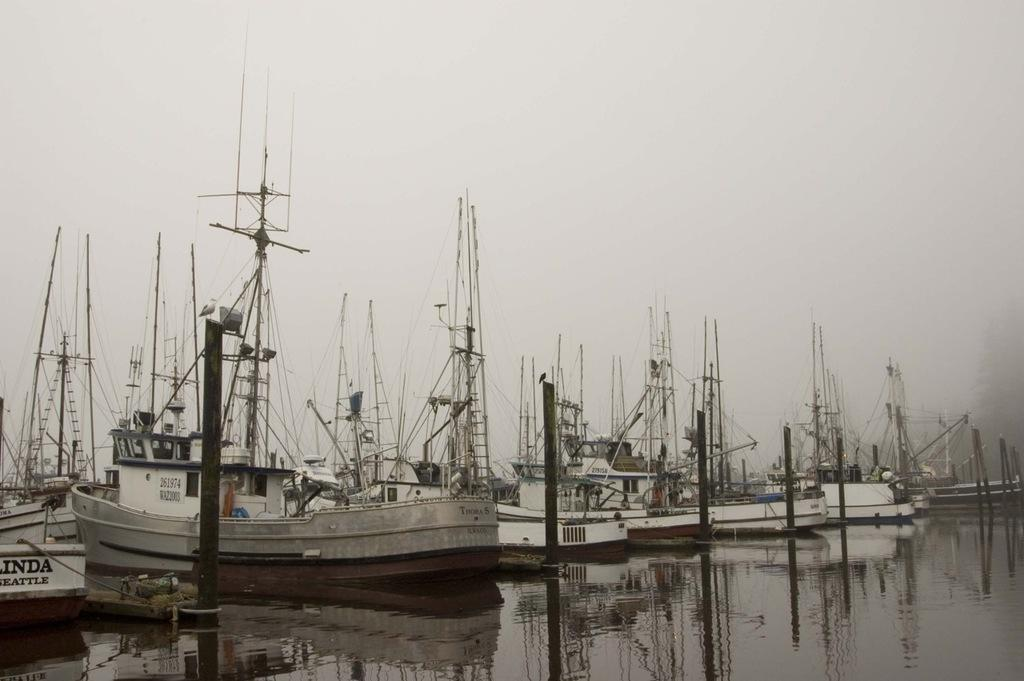<image>
Relay a brief, clear account of the picture shown. bunch of fishing boats, the closest one has Linda Seattle on the back of it 